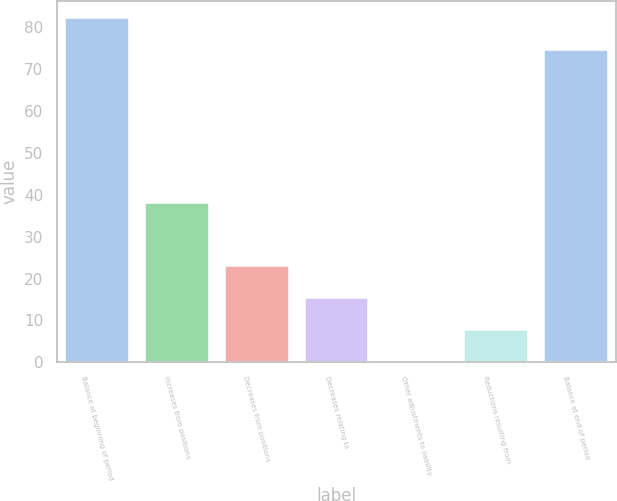Convert chart to OTSL. <chart><loc_0><loc_0><loc_500><loc_500><bar_chart><fcel>Balance at beginning of period<fcel>Increases from positions<fcel>Decreases from positions<fcel>Decreases relating to<fcel>Other adjustments to liability<fcel>Reductions resulting from<fcel>Balance at end of period<nl><fcel>82.16<fcel>38<fcel>22.88<fcel>15.32<fcel>0.2<fcel>7.76<fcel>74.6<nl></chart> 